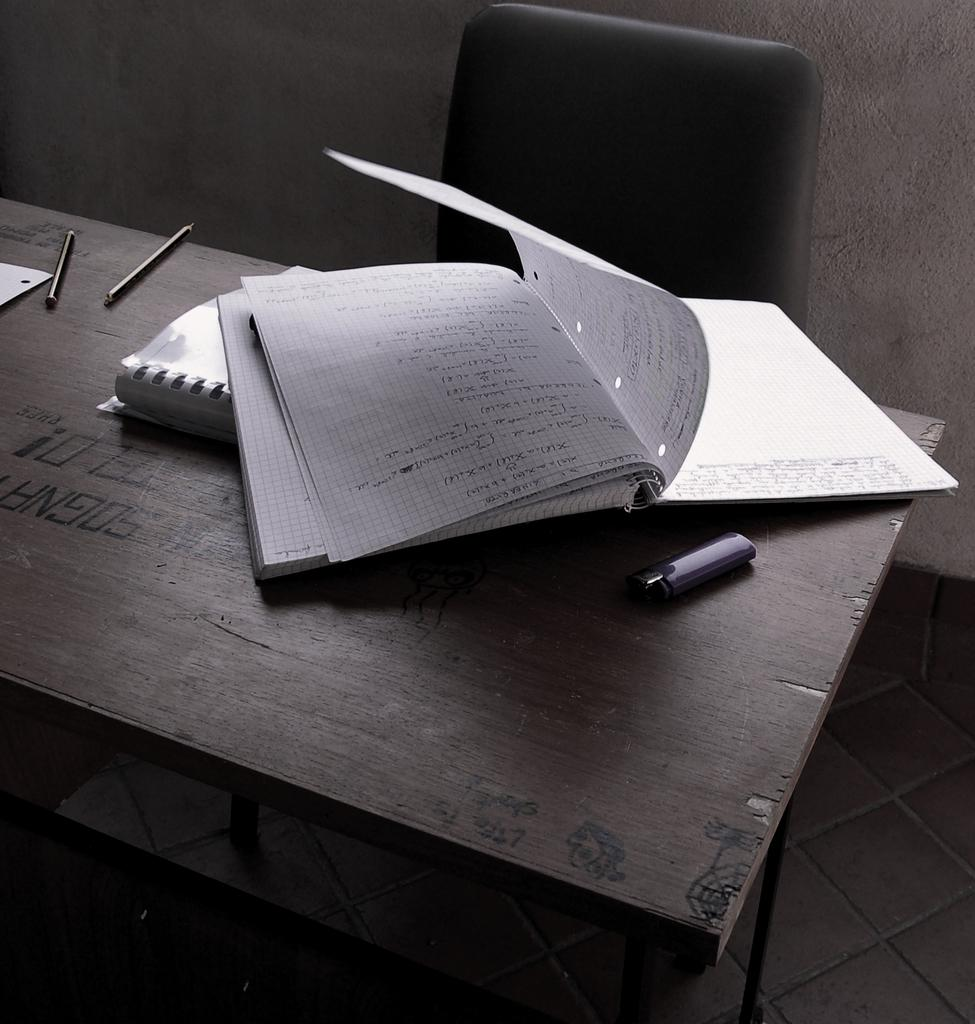<image>
Summarize the visual content of the image. A notebook is on a wooden desk that has the letters SOGNA written on it. 